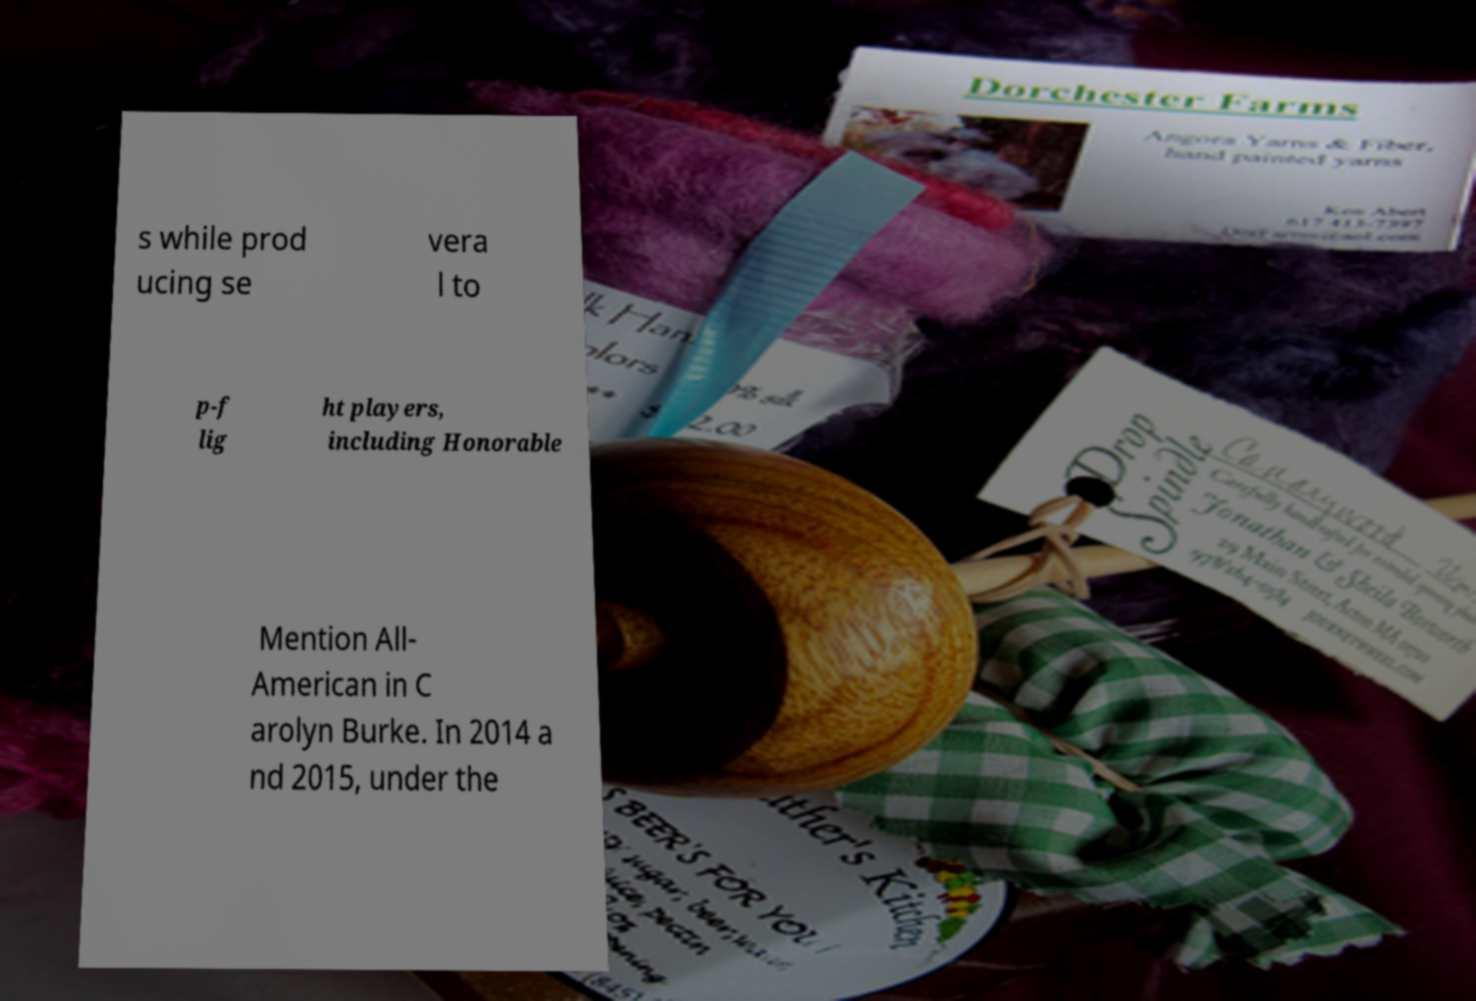What messages or text are displayed in this image? I need them in a readable, typed format. s while prod ucing se vera l to p-f lig ht players, including Honorable Mention All- American in C arolyn Burke. In 2014 a nd 2015, under the 